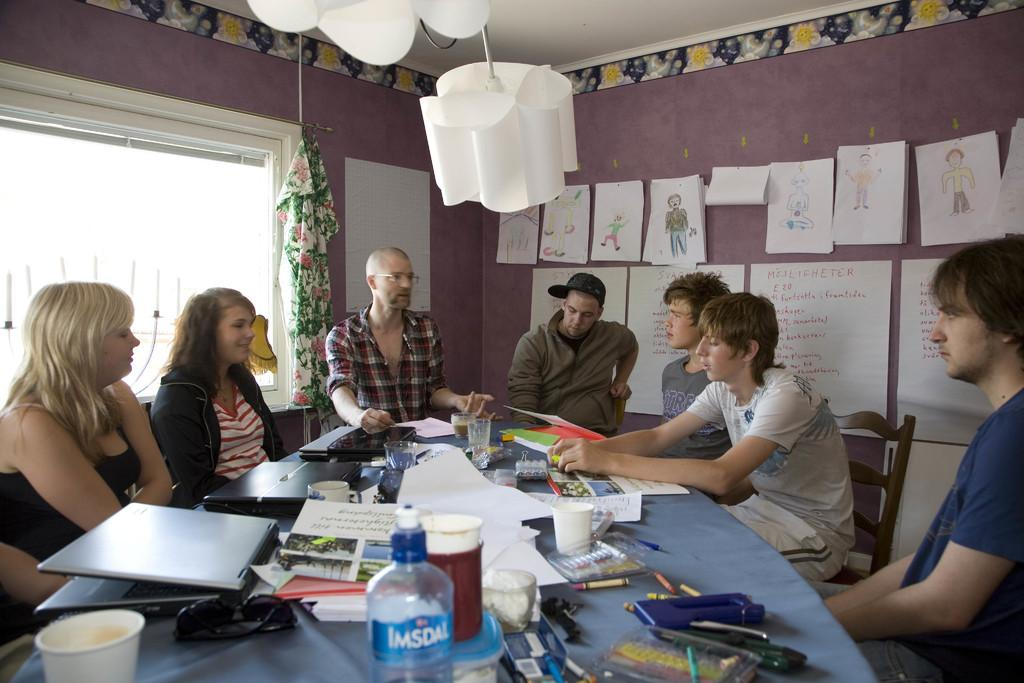What are the people in the image doing? The people in the image are sitting on the table. What can be seen hanging from the roof in the image? Stationery items and white hangings are attached to the roof. How many cents are visible on the table in the image? There is no mention of any currency or coins in the image, so it is not possible to determine the number of cents. 